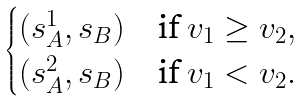<formula> <loc_0><loc_0><loc_500><loc_500>\begin{cases} ( s _ { A } ^ { 1 } , s _ { B } ) & \text {if } v _ { 1 } \geq v _ { 2 } , \\ ( s _ { A } ^ { 2 } , s _ { B } ) & \text {if } v _ { 1 } < v _ { 2 } . \end{cases}</formula> 